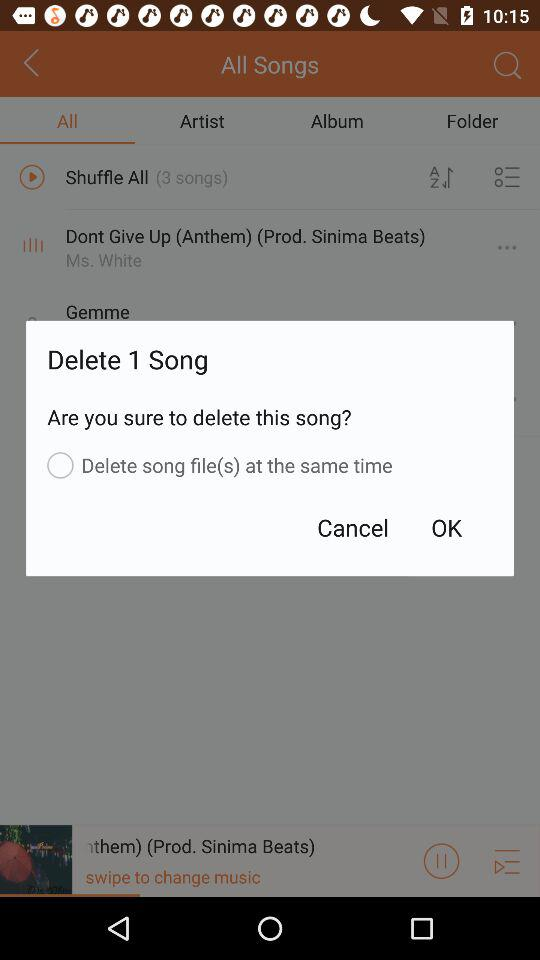Who is listed in "Artist"?
When the provided information is insufficient, respond with <no answer>. <no answer> 